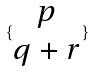<formula> <loc_0><loc_0><loc_500><loc_500>\{ \begin{matrix} p \\ q + r \end{matrix} \}</formula> 